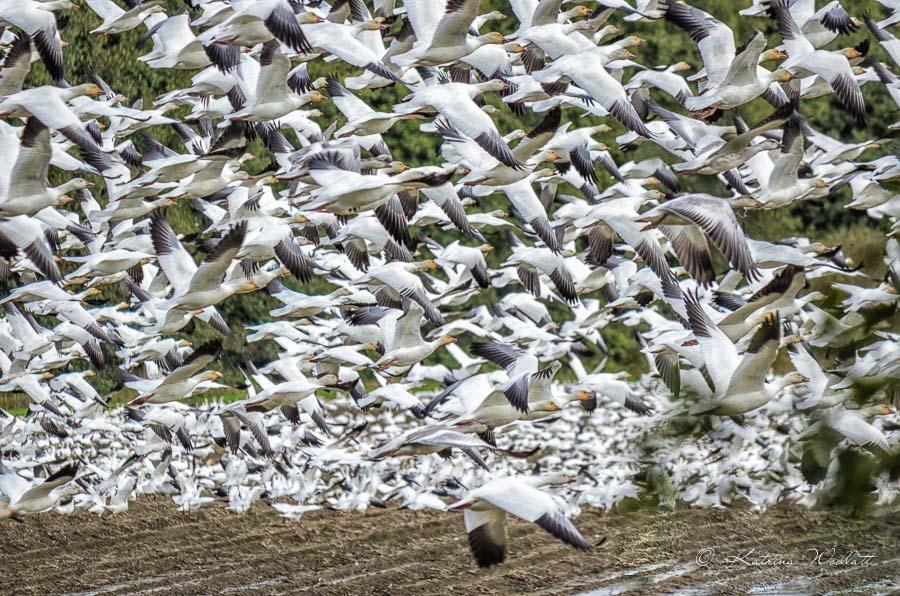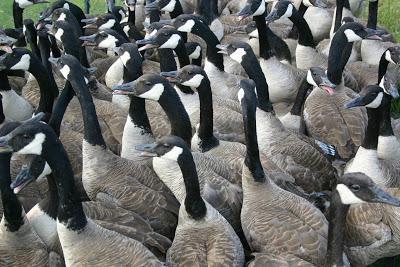The first image is the image on the left, the second image is the image on the right. Evaluate the accuracy of this statement regarding the images: "At least one goose has a black neck and beak, and a grey body.". Is it true? Answer yes or no. Yes. The first image is the image on the left, the second image is the image on the right. Evaluate the accuracy of this statement regarding the images: "In at least one image there are Blacked becked birds touching the water.". Is it true? Answer yes or no. No. 